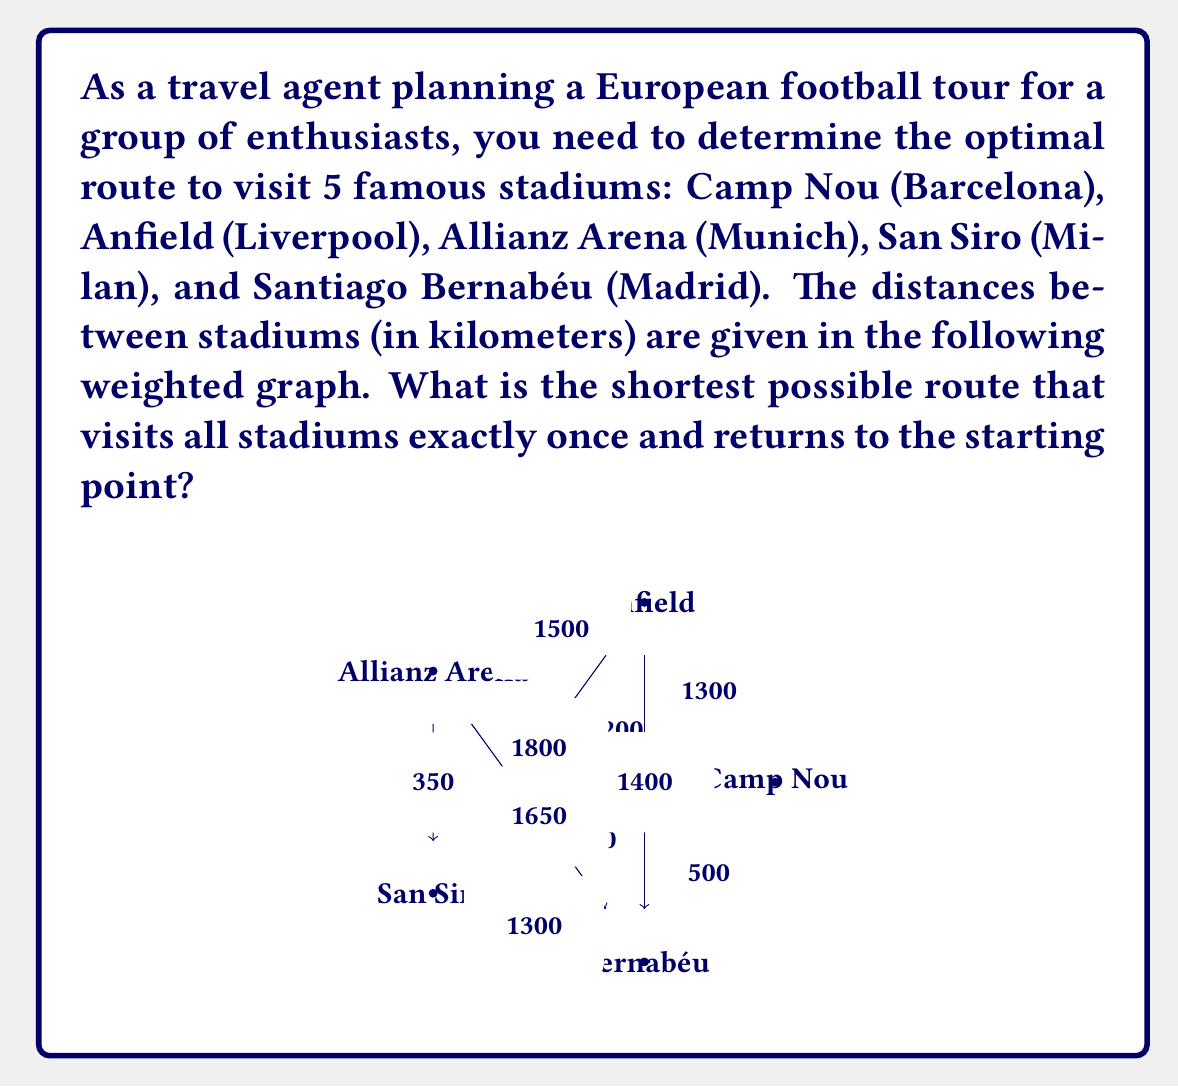Can you solve this math problem? To solve this problem, we need to find the Hamiltonian cycle with the minimum total weight in the given graph. This is known as the Traveling Salesman Problem (TSP), which is NP-hard. For a small graph like this, we can use a brute-force approach to find the optimal solution.

Steps to solve:

1. List all possible permutations of the 5 stadiums.
2. For each permutation, calculate the total distance of the tour.
3. Find the permutation with the minimum total distance.

Let's represent the stadiums as:
A: Camp Nou
B: Anfield
C: Allianz Arena
D: San Siro
E: Santiago Bernabéu

There are $(5-1)! = 24$ possible permutations (we fix the starting point as A).

Some example calculations:

1. A -> B -> C -> D -> E -> A
   Distance = 1300 + 1500 + 350 + 1300 + 500 = 4950 km

2. A -> B -> C -> E -> D -> A
   Distance = 1300 + 1500 + 1650 + 1300 + 850 = 6600 km

3. A -> C -> B -> D -> E -> A
   Distance = 1200 + 1500 + 1800 + 1300 + 500 = 6300 km

After calculating all 24 permutations, we find that the minimum distance is achieved by the following route:

A -> E -> B -> C -> D -> A

The total distance for this route is:
500 + 1400 + 1500 + 350 + 850 = 4600 km

This is the optimal route for the European football stadium tour.
Answer: The shortest possible route is Camp Nou -> Santiago Bernabéu -> Anfield -> Allianz Arena -> San Siro -> Camp Nou, with a total distance of 4600 km. 